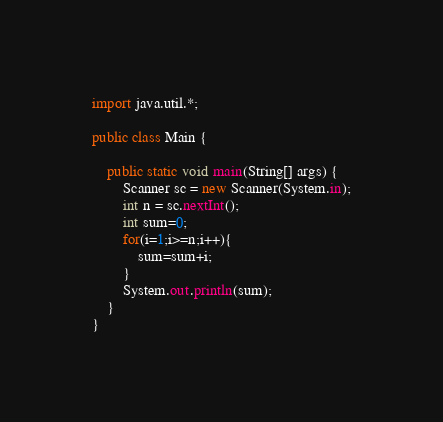Convert code to text. <code><loc_0><loc_0><loc_500><loc_500><_Java_>import java.util.*;

public class Main {

    public static void main(String[] args) {
        Scanner sc = new Scanner(System.in);
        int n = sc.nextInt();
        int sum=0;
        for(i=1;i>=n;i++){
            sum=sum+i;
        }
        System.out.println(sum);
    }
}
</code> 